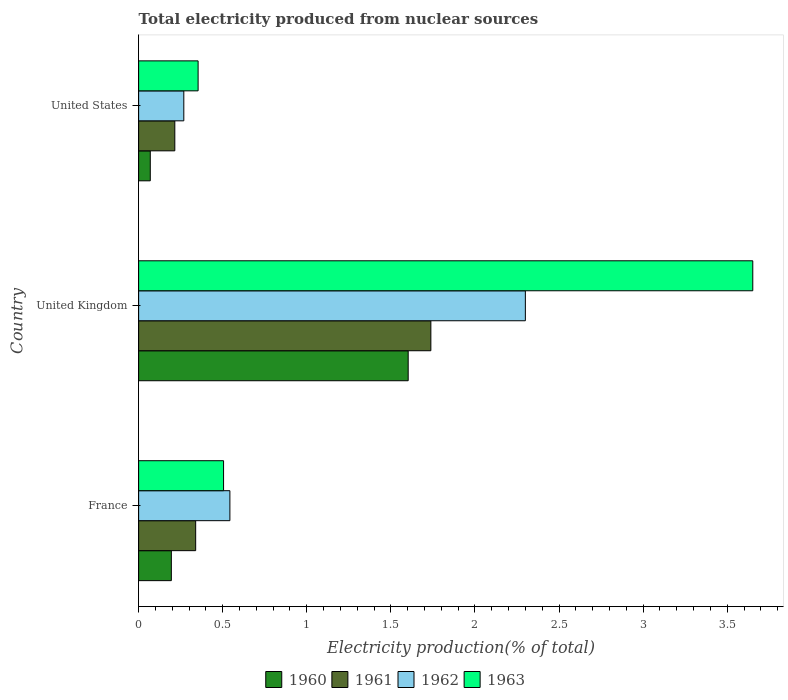Are the number of bars on each tick of the Y-axis equal?
Keep it short and to the point. Yes. How many bars are there on the 1st tick from the top?
Give a very brief answer. 4. What is the total electricity produced in 1962 in France?
Make the answer very short. 0.54. Across all countries, what is the maximum total electricity produced in 1962?
Your answer should be very brief. 2.3. Across all countries, what is the minimum total electricity produced in 1960?
Provide a short and direct response. 0.07. In which country was the total electricity produced in 1963 maximum?
Provide a short and direct response. United Kingdom. What is the total total electricity produced in 1962 in the graph?
Offer a very short reply. 3.11. What is the difference between the total electricity produced in 1963 in France and that in United Kingdom?
Give a very brief answer. -3.15. What is the difference between the total electricity produced in 1962 in United States and the total electricity produced in 1963 in United Kingdom?
Keep it short and to the point. -3.38. What is the average total electricity produced in 1963 per country?
Ensure brevity in your answer.  1.5. What is the difference between the total electricity produced in 1962 and total electricity produced in 1961 in France?
Ensure brevity in your answer.  0.2. In how many countries, is the total electricity produced in 1961 greater than 2.7 %?
Your response must be concise. 0. What is the ratio of the total electricity produced in 1963 in France to that in United Kingdom?
Make the answer very short. 0.14. Is the difference between the total electricity produced in 1962 in United Kingdom and United States greater than the difference between the total electricity produced in 1961 in United Kingdom and United States?
Give a very brief answer. Yes. What is the difference between the highest and the second highest total electricity produced in 1962?
Ensure brevity in your answer.  1.76. What is the difference between the highest and the lowest total electricity produced in 1963?
Provide a short and direct response. 3.3. In how many countries, is the total electricity produced in 1961 greater than the average total electricity produced in 1961 taken over all countries?
Your response must be concise. 1. Is the sum of the total electricity produced in 1963 in France and United Kingdom greater than the maximum total electricity produced in 1960 across all countries?
Keep it short and to the point. Yes. Is it the case that in every country, the sum of the total electricity produced in 1961 and total electricity produced in 1960 is greater than the total electricity produced in 1962?
Offer a terse response. No. Are all the bars in the graph horizontal?
Provide a succinct answer. Yes. How many countries are there in the graph?
Offer a very short reply. 3. Where does the legend appear in the graph?
Your response must be concise. Bottom center. How many legend labels are there?
Offer a very short reply. 4. How are the legend labels stacked?
Offer a very short reply. Horizontal. What is the title of the graph?
Give a very brief answer. Total electricity produced from nuclear sources. What is the label or title of the X-axis?
Keep it short and to the point. Electricity production(% of total). What is the label or title of the Y-axis?
Your answer should be compact. Country. What is the Electricity production(% of total) in 1960 in France?
Your answer should be compact. 0.19. What is the Electricity production(% of total) in 1961 in France?
Give a very brief answer. 0.34. What is the Electricity production(% of total) in 1962 in France?
Your answer should be very brief. 0.54. What is the Electricity production(% of total) in 1963 in France?
Keep it short and to the point. 0.51. What is the Electricity production(% of total) in 1960 in United Kingdom?
Offer a terse response. 1.6. What is the Electricity production(% of total) in 1961 in United Kingdom?
Give a very brief answer. 1.74. What is the Electricity production(% of total) of 1962 in United Kingdom?
Keep it short and to the point. 2.3. What is the Electricity production(% of total) of 1963 in United Kingdom?
Offer a very short reply. 3.65. What is the Electricity production(% of total) in 1960 in United States?
Provide a succinct answer. 0.07. What is the Electricity production(% of total) of 1961 in United States?
Offer a terse response. 0.22. What is the Electricity production(% of total) of 1962 in United States?
Your response must be concise. 0.27. What is the Electricity production(% of total) in 1963 in United States?
Your response must be concise. 0.35. Across all countries, what is the maximum Electricity production(% of total) of 1960?
Offer a very short reply. 1.6. Across all countries, what is the maximum Electricity production(% of total) of 1961?
Ensure brevity in your answer.  1.74. Across all countries, what is the maximum Electricity production(% of total) of 1962?
Ensure brevity in your answer.  2.3. Across all countries, what is the maximum Electricity production(% of total) in 1963?
Offer a terse response. 3.65. Across all countries, what is the minimum Electricity production(% of total) in 1960?
Make the answer very short. 0.07. Across all countries, what is the minimum Electricity production(% of total) of 1961?
Ensure brevity in your answer.  0.22. Across all countries, what is the minimum Electricity production(% of total) of 1962?
Offer a very short reply. 0.27. Across all countries, what is the minimum Electricity production(% of total) of 1963?
Offer a very short reply. 0.35. What is the total Electricity production(% of total) of 1960 in the graph?
Ensure brevity in your answer.  1.87. What is the total Electricity production(% of total) in 1961 in the graph?
Your answer should be compact. 2.29. What is the total Electricity production(% of total) of 1962 in the graph?
Give a very brief answer. 3.11. What is the total Electricity production(% of total) in 1963 in the graph?
Ensure brevity in your answer.  4.51. What is the difference between the Electricity production(% of total) of 1960 in France and that in United Kingdom?
Offer a terse response. -1.41. What is the difference between the Electricity production(% of total) of 1961 in France and that in United Kingdom?
Make the answer very short. -1.4. What is the difference between the Electricity production(% of total) of 1962 in France and that in United Kingdom?
Keep it short and to the point. -1.76. What is the difference between the Electricity production(% of total) of 1963 in France and that in United Kingdom?
Provide a short and direct response. -3.15. What is the difference between the Electricity production(% of total) in 1960 in France and that in United States?
Your response must be concise. 0.13. What is the difference between the Electricity production(% of total) of 1961 in France and that in United States?
Offer a terse response. 0.12. What is the difference between the Electricity production(% of total) of 1962 in France and that in United States?
Offer a terse response. 0.27. What is the difference between the Electricity production(% of total) in 1963 in France and that in United States?
Your answer should be very brief. 0.15. What is the difference between the Electricity production(% of total) in 1960 in United Kingdom and that in United States?
Make the answer very short. 1.53. What is the difference between the Electricity production(% of total) of 1961 in United Kingdom and that in United States?
Your answer should be compact. 1.52. What is the difference between the Electricity production(% of total) of 1962 in United Kingdom and that in United States?
Your response must be concise. 2.03. What is the difference between the Electricity production(% of total) of 1963 in United Kingdom and that in United States?
Provide a succinct answer. 3.3. What is the difference between the Electricity production(% of total) in 1960 in France and the Electricity production(% of total) in 1961 in United Kingdom?
Make the answer very short. -1.54. What is the difference between the Electricity production(% of total) in 1960 in France and the Electricity production(% of total) in 1962 in United Kingdom?
Make the answer very short. -2.11. What is the difference between the Electricity production(% of total) in 1960 in France and the Electricity production(% of total) in 1963 in United Kingdom?
Your answer should be very brief. -3.46. What is the difference between the Electricity production(% of total) of 1961 in France and the Electricity production(% of total) of 1962 in United Kingdom?
Ensure brevity in your answer.  -1.96. What is the difference between the Electricity production(% of total) of 1961 in France and the Electricity production(% of total) of 1963 in United Kingdom?
Keep it short and to the point. -3.31. What is the difference between the Electricity production(% of total) of 1962 in France and the Electricity production(% of total) of 1963 in United Kingdom?
Your answer should be very brief. -3.11. What is the difference between the Electricity production(% of total) in 1960 in France and the Electricity production(% of total) in 1961 in United States?
Make the answer very short. -0.02. What is the difference between the Electricity production(% of total) in 1960 in France and the Electricity production(% of total) in 1962 in United States?
Ensure brevity in your answer.  -0.07. What is the difference between the Electricity production(% of total) in 1960 in France and the Electricity production(% of total) in 1963 in United States?
Your answer should be compact. -0.16. What is the difference between the Electricity production(% of total) in 1961 in France and the Electricity production(% of total) in 1962 in United States?
Provide a succinct answer. 0.07. What is the difference between the Electricity production(% of total) of 1961 in France and the Electricity production(% of total) of 1963 in United States?
Your response must be concise. -0.01. What is the difference between the Electricity production(% of total) in 1962 in France and the Electricity production(% of total) in 1963 in United States?
Offer a very short reply. 0.19. What is the difference between the Electricity production(% of total) of 1960 in United Kingdom and the Electricity production(% of total) of 1961 in United States?
Provide a short and direct response. 1.39. What is the difference between the Electricity production(% of total) in 1960 in United Kingdom and the Electricity production(% of total) in 1962 in United States?
Your response must be concise. 1.33. What is the difference between the Electricity production(% of total) of 1960 in United Kingdom and the Electricity production(% of total) of 1963 in United States?
Keep it short and to the point. 1.25. What is the difference between the Electricity production(% of total) in 1961 in United Kingdom and the Electricity production(% of total) in 1962 in United States?
Your response must be concise. 1.47. What is the difference between the Electricity production(% of total) in 1961 in United Kingdom and the Electricity production(% of total) in 1963 in United States?
Ensure brevity in your answer.  1.38. What is the difference between the Electricity production(% of total) in 1962 in United Kingdom and the Electricity production(% of total) in 1963 in United States?
Your answer should be very brief. 1.95. What is the average Electricity production(% of total) of 1960 per country?
Offer a very short reply. 0.62. What is the average Electricity production(% of total) in 1961 per country?
Provide a short and direct response. 0.76. What is the average Electricity production(% of total) in 1962 per country?
Give a very brief answer. 1.04. What is the average Electricity production(% of total) of 1963 per country?
Offer a terse response. 1.5. What is the difference between the Electricity production(% of total) in 1960 and Electricity production(% of total) in 1961 in France?
Offer a very short reply. -0.14. What is the difference between the Electricity production(% of total) of 1960 and Electricity production(% of total) of 1962 in France?
Your answer should be very brief. -0.35. What is the difference between the Electricity production(% of total) in 1960 and Electricity production(% of total) in 1963 in France?
Provide a short and direct response. -0.31. What is the difference between the Electricity production(% of total) of 1961 and Electricity production(% of total) of 1962 in France?
Ensure brevity in your answer.  -0.2. What is the difference between the Electricity production(% of total) in 1961 and Electricity production(% of total) in 1963 in France?
Offer a terse response. -0.17. What is the difference between the Electricity production(% of total) of 1962 and Electricity production(% of total) of 1963 in France?
Ensure brevity in your answer.  0.04. What is the difference between the Electricity production(% of total) of 1960 and Electricity production(% of total) of 1961 in United Kingdom?
Make the answer very short. -0.13. What is the difference between the Electricity production(% of total) of 1960 and Electricity production(% of total) of 1962 in United Kingdom?
Offer a terse response. -0.7. What is the difference between the Electricity production(% of total) of 1960 and Electricity production(% of total) of 1963 in United Kingdom?
Provide a short and direct response. -2.05. What is the difference between the Electricity production(% of total) of 1961 and Electricity production(% of total) of 1962 in United Kingdom?
Make the answer very short. -0.56. What is the difference between the Electricity production(% of total) of 1961 and Electricity production(% of total) of 1963 in United Kingdom?
Provide a short and direct response. -1.91. What is the difference between the Electricity production(% of total) in 1962 and Electricity production(% of total) in 1963 in United Kingdom?
Your response must be concise. -1.35. What is the difference between the Electricity production(% of total) in 1960 and Electricity production(% of total) in 1961 in United States?
Give a very brief answer. -0.15. What is the difference between the Electricity production(% of total) in 1960 and Electricity production(% of total) in 1962 in United States?
Make the answer very short. -0.2. What is the difference between the Electricity production(% of total) in 1960 and Electricity production(% of total) in 1963 in United States?
Ensure brevity in your answer.  -0.28. What is the difference between the Electricity production(% of total) in 1961 and Electricity production(% of total) in 1962 in United States?
Provide a succinct answer. -0.05. What is the difference between the Electricity production(% of total) of 1961 and Electricity production(% of total) of 1963 in United States?
Your response must be concise. -0.14. What is the difference between the Electricity production(% of total) of 1962 and Electricity production(% of total) of 1963 in United States?
Make the answer very short. -0.09. What is the ratio of the Electricity production(% of total) of 1960 in France to that in United Kingdom?
Your response must be concise. 0.12. What is the ratio of the Electricity production(% of total) in 1961 in France to that in United Kingdom?
Your response must be concise. 0.2. What is the ratio of the Electricity production(% of total) in 1962 in France to that in United Kingdom?
Ensure brevity in your answer.  0.24. What is the ratio of the Electricity production(% of total) of 1963 in France to that in United Kingdom?
Give a very brief answer. 0.14. What is the ratio of the Electricity production(% of total) in 1960 in France to that in United States?
Your answer should be very brief. 2.81. What is the ratio of the Electricity production(% of total) of 1961 in France to that in United States?
Keep it short and to the point. 1.58. What is the ratio of the Electricity production(% of total) in 1962 in France to that in United States?
Offer a terse response. 2.02. What is the ratio of the Electricity production(% of total) in 1963 in France to that in United States?
Give a very brief answer. 1.43. What is the ratio of the Electricity production(% of total) in 1960 in United Kingdom to that in United States?
Ensure brevity in your answer.  23.14. What is the ratio of the Electricity production(% of total) of 1961 in United Kingdom to that in United States?
Make the answer very short. 8.08. What is the ratio of the Electricity production(% of total) of 1962 in United Kingdom to that in United States?
Your answer should be compact. 8.56. What is the ratio of the Electricity production(% of total) in 1963 in United Kingdom to that in United States?
Offer a very short reply. 10.32. What is the difference between the highest and the second highest Electricity production(% of total) in 1960?
Provide a succinct answer. 1.41. What is the difference between the highest and the second highest Electricity production(% of total) of 1961?
Make the answer very short. 1.4. What is the difference between the highest and the second highest Electricity production(% of total) of 1962?
Provide a succinct answer. 1.76. What is the difference between the highest and the second highest Electricity production(% of total) of 1963?
Your answer should be compact. 3.15. What is the difference between the highest and the lowest Electricity production(% of total) in 1960?
Your response must be concise. 1.53. What is the difference between the highest and the lowest Electricity production(% of total) in 1961?
Offer a very short reply. 1.52. What is the difference between the highest and the lowest Electricity production(% of total) of 1962?
Offer a very short reply. 2.03. What is the difference between the highest and the lowest Electricity production(% of total) in 1963?
Your answer should be compact. 3.3. 